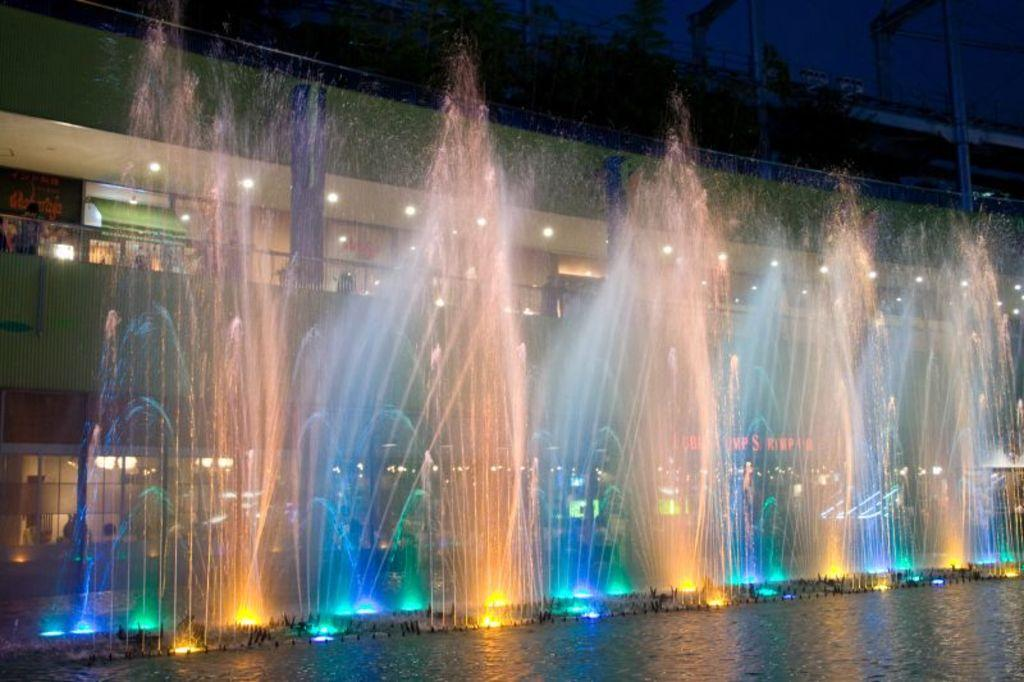What is located at the bottom of the image? There is water with fountains at the bottom of the image. What can be seen behind the fountains? There is a building behind the fountains. What architectural features are present on the building? The building has walls, pillars, and lights. Can you see a person walking near the fountains in the image? There is no person visible in the image; it only shows water with fountains, a building, and the building's features. Are there any planes flying over the building in the image? There are no planes visible in the image; it only shows water with fountains, a building, and the building's features. 